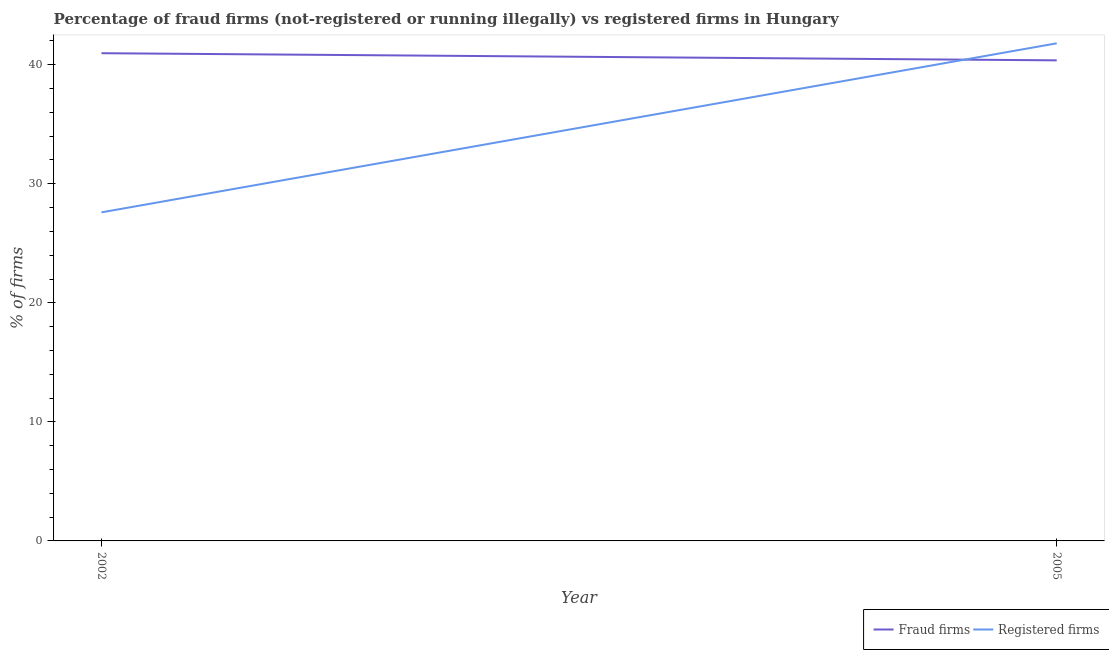Does the line corresponding to percentage of fraud firms intersect with the line corresponding to percentage of registered firms?
Provide a succinct answer. Yes. Is the number of lines equal to the number of legend labels?
Ensure brevity in your answer.  Yes. What is the percentage of fraud firms in 2002?
Your answer should be compact. 40.97. Across all years, what is the maximum percentage of registered firms?
Make the answer very short. 41.8. Across all years, what is the minimum percentage of fraud firms?
Your response must be concise. 40.37. What is the total percentage of registered firms in the graph?
Provide a short and direct response. 69.4. What is the difference between the percentage of fraud firms in 2002 and that in 2005?
Provide a succinct answer. 0.6. What is the difference between the percentage of fraud firms in 2005 and the percentage of registered firms in 2002?
Offer a terse response. 12.77. What is the average percentage of fraud firms per year?
Give a very brief answer. 40.67. In the year 2005, what is the difference between the percentage of fraud firms and percentage of registered firms?
Your response must be concise. -1.43. In how many years, is the percentage of registered firms greater than 12 %?
Provide a succinct answer. 2. What is the ratio of the percentage of fraud firms in 2002 to that in 2005?
Your answer should be very brief. 1.01. Does the percentage of fraud firms monotonically increase over the years?
Give a very brief answer. No. Is the percentage of registered firms strictly greater than the percentage of fraud firms over the years?
Keep it short and to the point. No. How many lines are there?
Make the answer very short. 2. Does the graph contain any zero values?
Keep it short and to the point. No. Where does the legend appear in the graph?
Your answer should be compact. Bottom right. How many legend labels are there?
Offer a very short reply. 2. What is the title of the graph?
Make the answer very short. Percentage of fraud firms (not-registered or running illegally) vs registered firms in Hungary. Does "RDB concessional" appear as one of the legend labels in the graph?
Your response must be concise. No. What is the label or title of the Y-axis?
Ensure brevity in your answer.  % of firms. What is the % of firms of Fraud firms in 2002?
Offer a terse response. 40.97. What is the % of firms of Registered firms in 2002?
Provide a short and direct response. 27.6. What is the % of firms in Fraud firms in 2005?
Make the answer very short. 40.37. What is the % of firms in Registered firms in 2005?
Keep it short and to the point. 41.8. Across all years, what is the maximum % of firms of Fraud firms?
Your answer should be compact. 40.97. Across all years, what is the maximum % of firms of Registered firms?
Give a very brief answer. 41.8. Across all years, what is the minimum % of firms of Fraud firms?
Your answer should be very brief. 40.37. Across all years, what is the minimum % of firms of Registered firms?
Provide a succinct answer. 27.6. What is the total % of firms in Fraud firms in the graph?
Provide a succinct answer. 81.34. What is the total % of firms of Registered firms in the graph?
Your response must be concise. 69.4. What is the difference between the % of firms in Fraud firms in 2002 and that in 2005?
Your answer should be very brief. 0.6. What is the difference between the % of firms of Registered firms in 2002 and that in 2005?
Give a very brief answer. -14.2. What is the difference between the % of firms in Fraud firms in 2002 and the % of firms in Registered firms in 2005?
Offer a terse response. -0.83. What is the average % of firms of Fraud firms per year?
Keep it short and to the point. 40.67. What is the average % of firms of Registered firms per year?
Provide a short and direct response. 34.7. In the year 2002, what is the difference between the % of firms in Fraud firms and % of firms in Registered firms?
Give a very brief answer. 13.37. In the year 2005, what is the difference between the % of firms of Fraud firms and % of firms of Registered firms?
Your response must be concise. -1.43. What is the ratio of the % of firms of Fraud firms in 2002 to that in 2005?
Provide a succinct answer. 1.01. What is the ratio of the % of firms of Registered firms in 2002 to that in 2005?
Provide a succinct answer. 0.66. What is the difference between the highest and the second highest % of firms of Fraud firms?
Offer a very short reply. 0.6. What is the difference between the highest and the lowest % of firms of Fraud firms?
Provide a short and direct response. 0.6. 